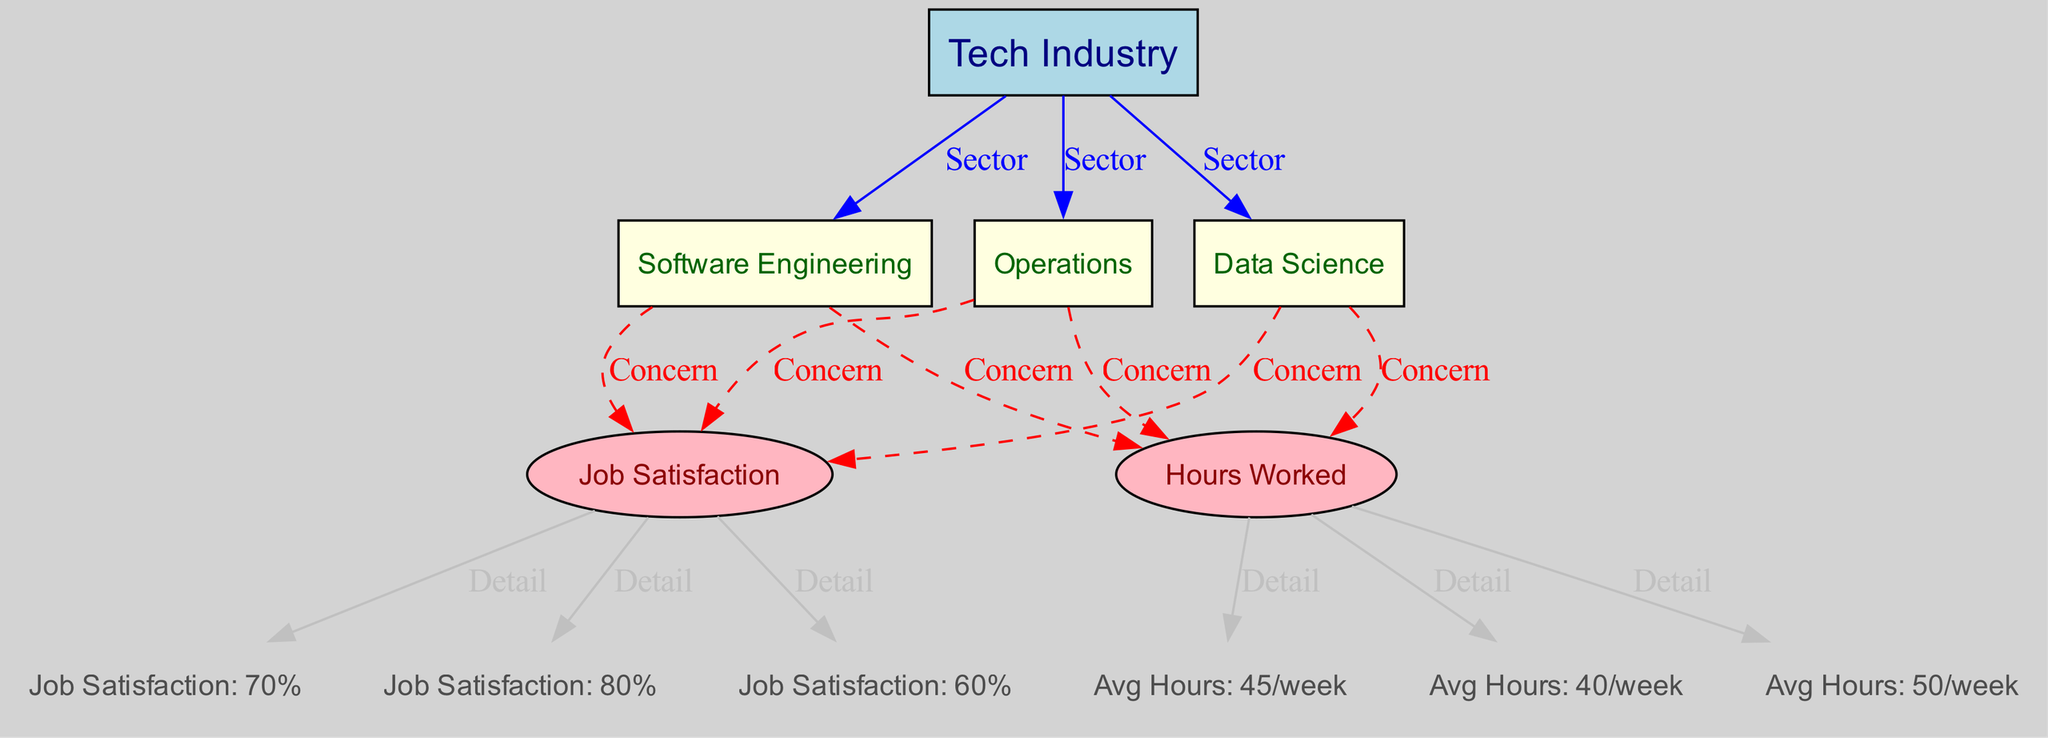What are the average hours worked in Software Engineering? The diagram shows a node labeled "Avg Hours: 45/week" connected to "Software Engineering" through a "Detail" edge. This clearly indicates that the average hours worked in Software Engineering is 45 hours per week.
Answer: 45/week What is the job satisfaction percentage in Data Science? In the diagram, there is a node labeled "Job Satisfaction: 80%" connected to "Data Science" which indicates the level of job satisfaction explicitly for this field.
Answer: 80% How many different tech industries are represented in the diagram? The diagram includes three distinct nodes representing different tech industries: "Software Engineering," "Data Science," and "Operations." Counting these gives a total of three industries.
Answer: 3 Which tech industry has the highest job satisfaction? Observing the job satisfaction nodes in the diagram, "Job Satisfaction: 80%" for Data Science is greater than "Job Satisfaction: 70%" for Software Engineering and "Job Satisfaction: 60%" for Operations. Hence, Data Science has the highest job satisfaction percentage.
Answer: Data Science Is there a direct relationship between hours worked and job satisfaction in Software Engineering? The diagram shows both "Hours Worked" and "Job Satisfaction" as concerns linked to "Software Engineering" but does not indicate a direct edge between them. Therefore, while they are both concerns, there is no direct relational edge linking them in the diagram.
Answer: No 